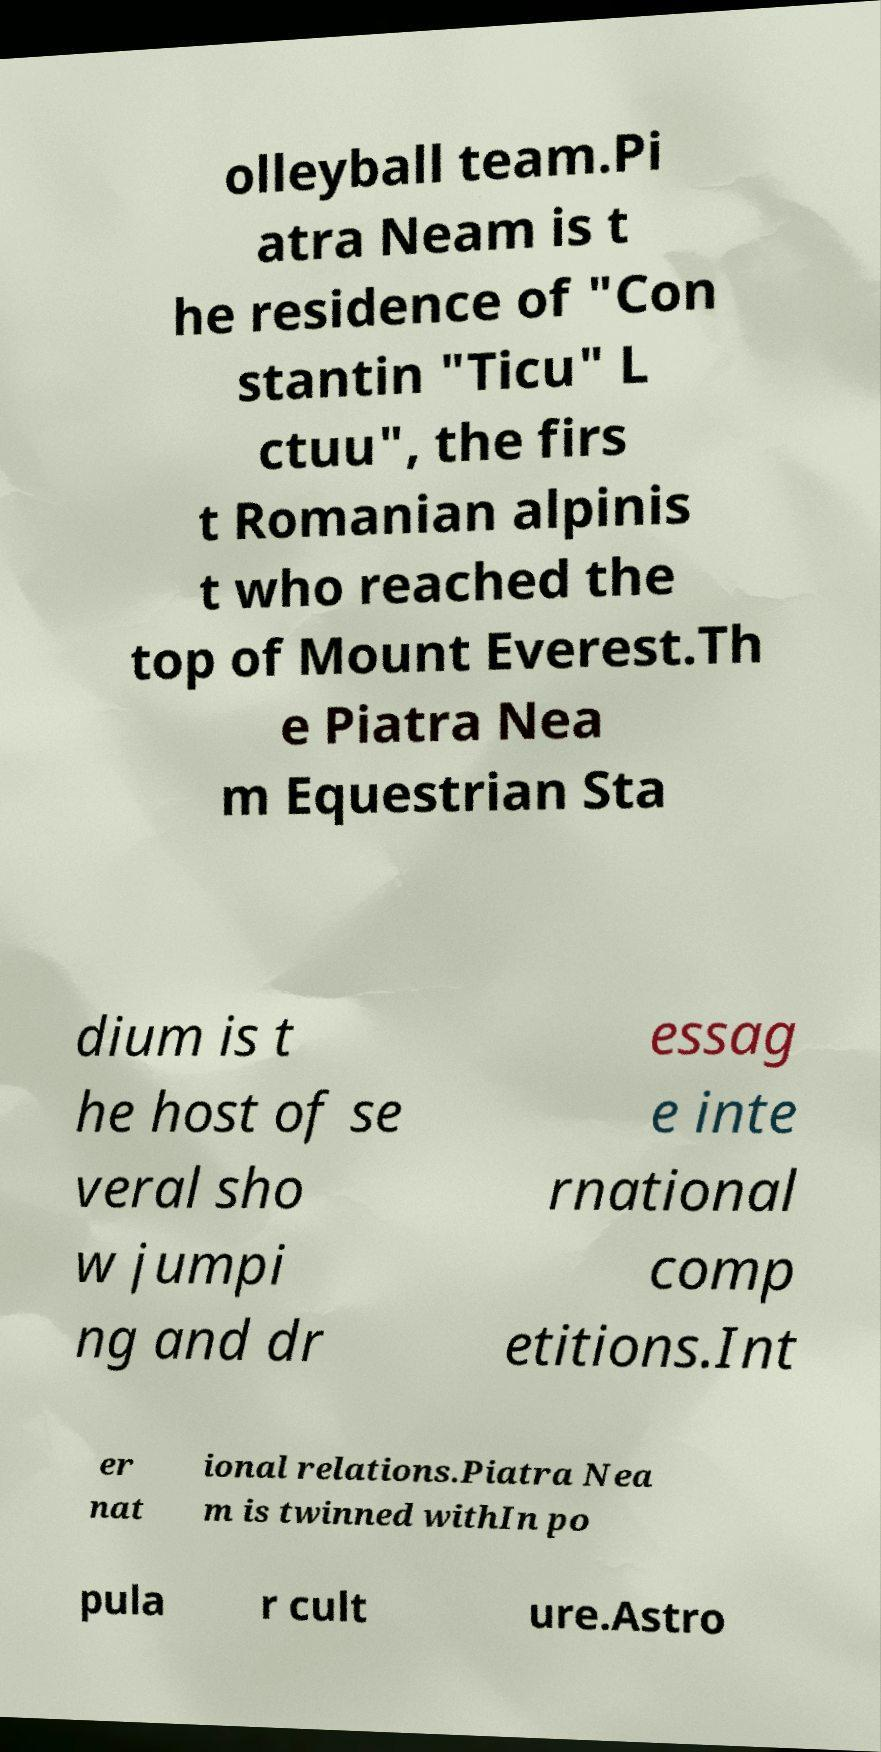For documentation purposes, I need the text within this image transcribed. Could you provide that? olleyball team.Pi atra Neam is t he residence of "Con stantin "Ticu" L ctuu", the firs t Romanian alpinis t who reached the top of Mount Everest.Th e Piatra Nea m Equestrian Sta dium is t he host of se veral sho w jumpi ng and dr essag e inte rnational comp etitions.Int er nat ional relations.Piatra Nea m is twinned withIn po pula r cult ure.Astro 